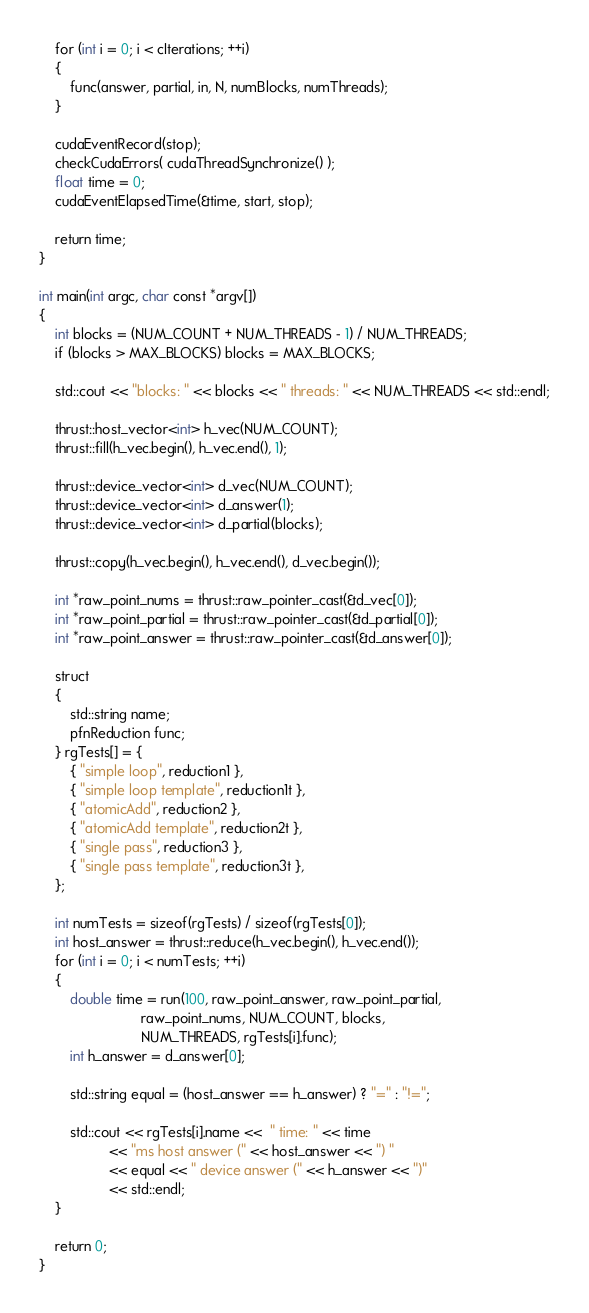Convert code to text. <code><loc_0><loc_0><loc_500><loc_500><_Cuda_>
    for (int i = 0; i < cIterations; ++i)
    {
        func(answer, partial, in, N, numBlocks, numThreads);
    }

    cudaEventRecord(stop);
    checkCudaErrors( cudaThreadSynchronize() );
    float time = 0;
    cudaEventElapsedTime(&time, start, stop);

    return time;
}

int main(int argc, char const *argv[])
{
    int blocks = (NUM_COUNT + NUM_THREADS - 1) / NUM_THREADS;
    if (blocks > MAX_BLOCKS) blocks = MAX_BLOCKS;

    std::cout << "blocks: " << blocks << " threads: " << NUM_THREADS << std::endl;

    thrust::host_vector<int> h_vec(NUM_COUNT);
    thrust::fill(h_vec.begin(), h_vec.end(), 1);

    thrust::device_vector<int> d_vec(NUM_COUNT);
    thrust::device_vector<int> d_answer(1);
    thrust::device_vector<int> d_partial(blocks);

    thrust::copy(h_vec.begin(), h_vec.end(), d_vec.begin());

    int *raw_point_nums = thrust::raw_pointer_cast(&d_vec[0]);
    int *raw_point_partial = thrust::raw_pointer_cast(&d_partial[0]);
    int *raw_point_answer = thrust::raw_pointer_cast(&d_answer[0]);

    struct
    {
        std::string name;
        pfnReduction func;
    } rgTests[] = {
        { "simple loop", reduction1 },
        { "simple loop template", reduction1t },
        { "atomicAdd", reduction2 },
        { "atomicAdd template", reduction2t },
        { "single pass", reduction3 },
        { "single pass template", reduction3t },        
    };

    int numTests = sizeof(rgTests) / sizeof(rgTests[0]);
    int host_answer = thrust::reduce(h_vec.begin(), h_vec.end());
    for (int i = 0; i < numTests; ++i)
    {
        double time = run(100, raw_point_answer, raw_point_partial, 
                          raw_point_nums, NUM_COUNT, blocks, 
                          NUM_THREADS, rgTests[i].func);
        int h_answer = d_answer[0];
        
        std::string equal = (host_answer == h_answer) ? "=" : "!=";

        std::cout << rgTests[i].name <<  " time: " << time 
                  << "ms host answer (" << host_answer << ") " 
                  << equal << " device answer (" << h_answer << ")" 
                  << std::endl;
    }

    return 0;
}</code> 